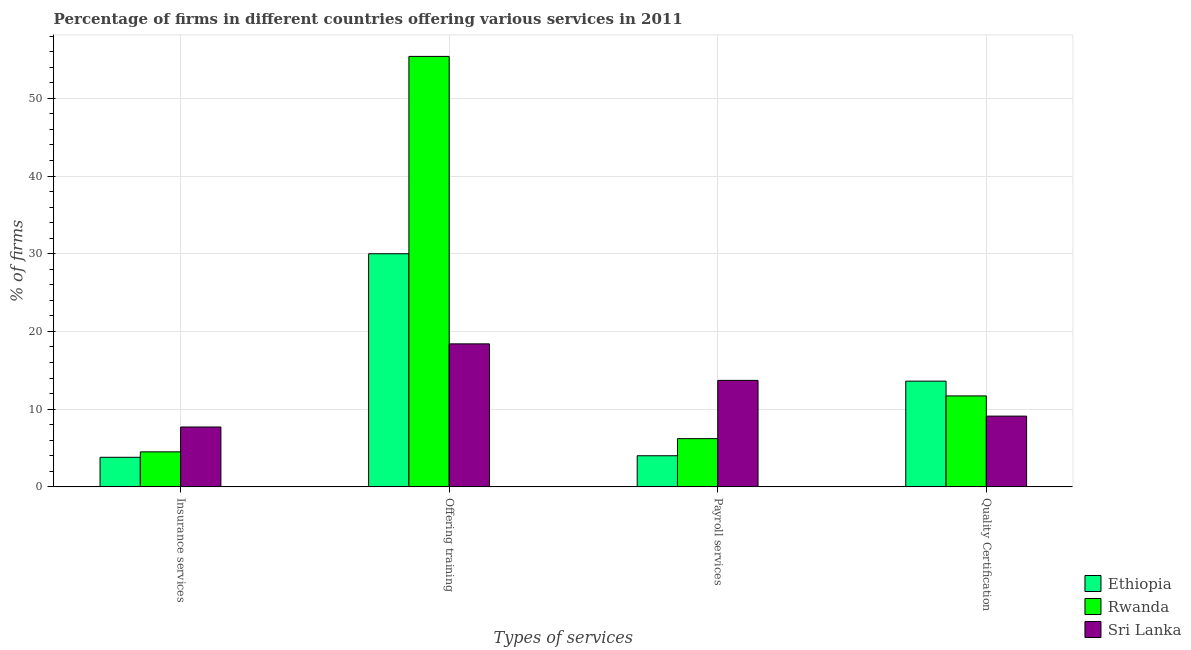Are the number of bars per tick equal to the number of legend labels?
Offer a terse response. Yes. How many bars are there on the 2nd tick from the left?
Your answer should be compact. 3. What is the label of the 1st group of bars from the left?
Your answer should be very brief. Insurance services. Across all countries, what is the minimum percentage of firms offering insurance services?
Offer a terse response. 3.8. In which country was the percentage of firms offering insurance services maximum?
Keep it short and to the point. Sri Lanka. In which country was the percentage of firms offering training minimum?
Offer a very short reply. Sri Lanka. What is the total percentage of firms offering training in the graph?
Make the answer very short. 103.8. What is the average percentage of firms offering quality certification per country?
Give a very brief answer. 11.47. What is the difference between the percentage of firms offering insurance services and percentage of firms offering training in Sri Lanka?
Give a very brief answer. -10.7. What is the ratio of the percentage of firms offering payroll services in Ethiopia to that in Sri Lanka?
Make the answer very short. 0.29. Is the difference between the percentage of firms offering insurance services in Sri Lanka and Ethiopia greater than the difference between the percentage of firms offering payroll services in Sri Lanka and Ethiopia?
Provide a short and direct response. No. What is the difference between the highest and the lowest percentage of firms offering training?
Offer a very short reply. 37. In how many countries, is the percentage of firms offering payroll services greater than the average percentage of firms offering payroll services taken over all countries?
Provide a succinct answer. 1. Is the sum of the percentage of firms offering quality certification in Sri Lanka and Rwanda greater than the maximum percentage of firms offering training across all countries?
Give a very brief answer. No. Is it the case that in every country, the sum of the percentage of firms offering payroll services and percentage of firms offering training is greater than the sum of percentage of firms offering insurance services and percentage of firms offering quality certification?
Make the answer very short. Yes. What does the 1st bar from the left in Quality Certification represents?
Ensure brevity in your answer.  Ethiopia. What does the 3rd bar from the right in Offering training represents?
Ensure brevity in your answer.  Ethiopia. How many countries are there in the graph?
Offer a terse response. 3. What is the difference between two consecutive major ticks on the Y-axis?
Provide a succinct answer. 10. Does the graph contain any zero values?
Offer a very short reply. No. Does the graph contain grids?
Provide a short and direct response. Yes. Where does the legend appear in the graph?
Your response must be concise. Bottom right. How many legend labels are there?
Your answer should be compact. 3. How are the legend labels stacked?
Your answer should be very brief. Vertical. What is the title of the graph?
Your answer should be compact. Percentage of firms in different countries offering various services in 2011. What is the label or title of the X-axis?
Give a very brief answer. Types of services. What is the label or title of the Y-axis?
Provide a succinct answer. % of firms. What is the % of firms in Rwanda in Insurance services?
Offer a very short reply. 4.5. What is the % of firms in Sri Lanka in Insurance services?
Your answer should be very brief. 7.7. What is the % of firms of Ethiopia in Offering training?
Provide a succinct answer. 30. What is the % of firms in Rwanda in Offering training?
Your answer should be compact. 55.4. What is the % of firms of Sri Lanka in Payroll services?
Make the answer very short. 13.7. Across all Types of services, what is the maximum % of firms in Rwanda?
Your answer should be very brief. 55.4. Across all Types of services, what is the maximum % of firms in Sri Lanka?
Your answer should be compact. 18.4. What is the total % of firms in Ethiopia in the graph?
Offer a terse response. 51.4. What is the total % of firms in Rwanda in the graph?
Ensure brevity in your answer.  77.8. What is the total % of firms of Sri Lanka in the graph?
Provide a short and direct response. 48.9. What is the difference between the % of firms in Ethiopia in Insurance services and that in Offering training?
Provide a succinct answer. -26.2. What is the difference between the % of firms in Rwanda in Insurance services and that in Offering training?
Make the answer very short. -50.9. What is the difference between the % of firms of Ethiopia in Insurance services and that in Payroll services?
Your response must be concise. -0.2. What is the difference between the % of firms of Sri Lanka in Insurance services and that in Payroll services?
Ensure brevity in your answer.  -6. What is the difference between the % of firms in Ethiopia in Insurance services and that in Quality Certification?
Provide a short and direct response. -9.8. What is the difference between the % of firms of Rwanda in Insurance services and that in Quality Certification?
Give a very brief answer. -7.2. What is the difference between the % of firms of Ethiopia in Offering training and that in Payroll services?
Your answer should be compact. 26. What is the difference between the % of firms of Rwanda in Offering training and that in Payroll services?
Offer a very short reply. 49.2. What is the difference between the % of firms of Rwanda in Offering training and that in Quality Certification?
Provide a succinct answer. 43.7. What is the difference between the % of firms in Ethiopia in Insurance services and the % of firms in Rwanda in Offering training?
Your answer should be compact. -51.6. What is the difference between the % of firms in Ethiopia in Insurance services and the % of firms in Sri Lanka in Offering training?
Provide a short and direct response. -14.6. What is the difference between the % of firms in Rwanda in Insurance services and the % of firms in Sri Lanka in Offering training?
Give a very brief answer. -13.9. What is the difference between the % of firms in Ethiopia in Insurance services and the % of firms in Rwanda in Payroll services?
Provide a succinct answer. -2.4. What is the difference between the % of firms of Ethiopia in Insurance services and the % of firms of Sri Lanka in Payroll services?
Your answer should be compact. -9.9. What is the difference between the % of firms of Rwanda in Insurance services and the % of firms of Sri Lanka in Payroll services?
Your response must be concise. -9.2. What is the difference between the % of firms of Ethiopia in Insurance services and the % of firms of Sri Lanka in Quality Certification?
Make the answer very short. -5.3. What is the difference between the % of firms of Ethiopia in Offering training and the % of firms of Rwanda in Payroll services?
Provide a succinct answer. 23.8. What is the difference between the % of firms of Rwanda in Offering training and the % of firms of Sri Lanka in Payroll services?
Keep it short and to the point. 41.7. What is the difference between the % of firms of Ethiopia in Offering training and the % of firms of Sri Lanka in Quality Certification?
Keep it short and to the point. 20.9. What is the difference between the % of firms in Rwanda in Offering training and the % of firms in Sri Lanka in Quality Certification?
Provide a succinct answer. 46.3. What is the difference between the % of firms of Ethiopia in Payroll services and the % of firms of Sri Lanka in Quality Certification?
Give a very brief answer. -5.1. What is the average % of firms in Ethiopia per Types of services?
Your answer should be very brief. 12.85. What is the average % of firms of Rwanda per Types of services?
Ensure brevity in your answer.  19.45. What is the average % of firms in Sri Lanka per Types of services?
Your answer should be compact. 12.22. What is the difference between the % of firms of Ethiopia and % of firms of Sri Lanka in Insurance services?
Your response must be concise. -3.9. What is the difference between the % of firms in Rwanda and % of firms in Sri Lanka in Insurance services?
Offer a very short reply. -3.2. What is the difference between the % of firms of Ethiopia and % of firms of Rwanda in Offering training?
Keep it short and to the point. -25.4. What is the difference between the % of firms in Ethiopia and % of firms in Sri Lanka in Offering training?
Provide a succinct answer. 11.6. What is the difference between the % of firms in Rwanda and % of firms in Sri Lanka in Offering training?
Provide a succinct answer. 37. What is the difference between the % of firms of Ethiopia and % of firms of Rwanda in Payroll services?
Keep it short and to the point. -2.2. What is the difference between the % of firms in Ethiopia and % of firms in Rwanda in Quality Certification?
Provide a short and direct response. 1.9. What is the ratio of the % of firms of Ethiopia in Insurance services to that in Offering training?
Your answer should be very brief. 0.13. What is the ratio of the % of firms of Rwanda in Insurance services to that in Offering training?
Ensure brevity in your answer.  0.08. What is the ratio of the % of firms in Sri Lanka in Insurance services to that in Offering training?
Provide a short and direct response. 0.42. What is the ratio of the % of firms of Ethiopia in Insurance services to that in Payroll services?
Give a very brief answer. 0.95. What is the ratio of the % of firms of Rwanda in Insurance services to that in Payroll services?
Provide a succinct answer. 0.73. What is the ratio of the % of firms of Sri Lanka in Insurance services to that in Payroll services?
Provide a succinct answer. 0.56. What is the ratio of the % of firms in Ethiopia in Insurance services to that in Quality Certification?
Your response must be concise. 0.28. What is the ratio of the % of firms in Rwanda in Insurance services to that in Quality Certification?
Provide a short and direct response. 0.38. What is the ratio of the % of firms of Sri Lanka in Insurance services to that in Quality Certification?
Ensure brevity in your answer.  0.85. What is the ratio of the % of firms in Rwanda in Offering training to that in Payroll services?
Provide a short and direct response. 8.94. What is the ratio of the % of firms of Sri Lanka in Offering training to that in Payroll services?
Your response must be concise. 1.34. What is the ratio of the % of firms in Ethiopia in Offering training to that in Quality Certification?
Offer a very short reply. 2.21. What is the ratio of the % of firms in Rwanda in Offering training to that in Quality Certification?
Provide a short and direct response. 4.74. What is the ratio of the % of firms in Sri Lanka in Offering training to that in Quality Certification?
Your answer should be very brief. 2.02. What is the ratio of the % of firms in Ethiopia in Payroll services to that in Quality Certification?
Ensure brevity in your answer.  0.29. What is the ratio of the % of firms of Rwanda in Payroll services to that in Quality Certification?
Offer a very short reply. 0.53. What is the ratio of the % of firms of Sri Lanka in Payroll services to that in Quality Certification?
Your answer should be compact. 1.51. What is the difference between the highest and the second highest % of firms in Rwanda?
Your answer should be very brief. 43.7. What is the difference between the highest and the second highest % of firms of Sri Lanka?
Keep it short and to the point. 4.7. What is the difference between the highest and the lowest % of firms in Ethiopia?
Your answer should be very brief. 26.2. What is the difference between the highest and the lowest % of firms in Rwanda?
Keep it short and to the point. 50.9. 